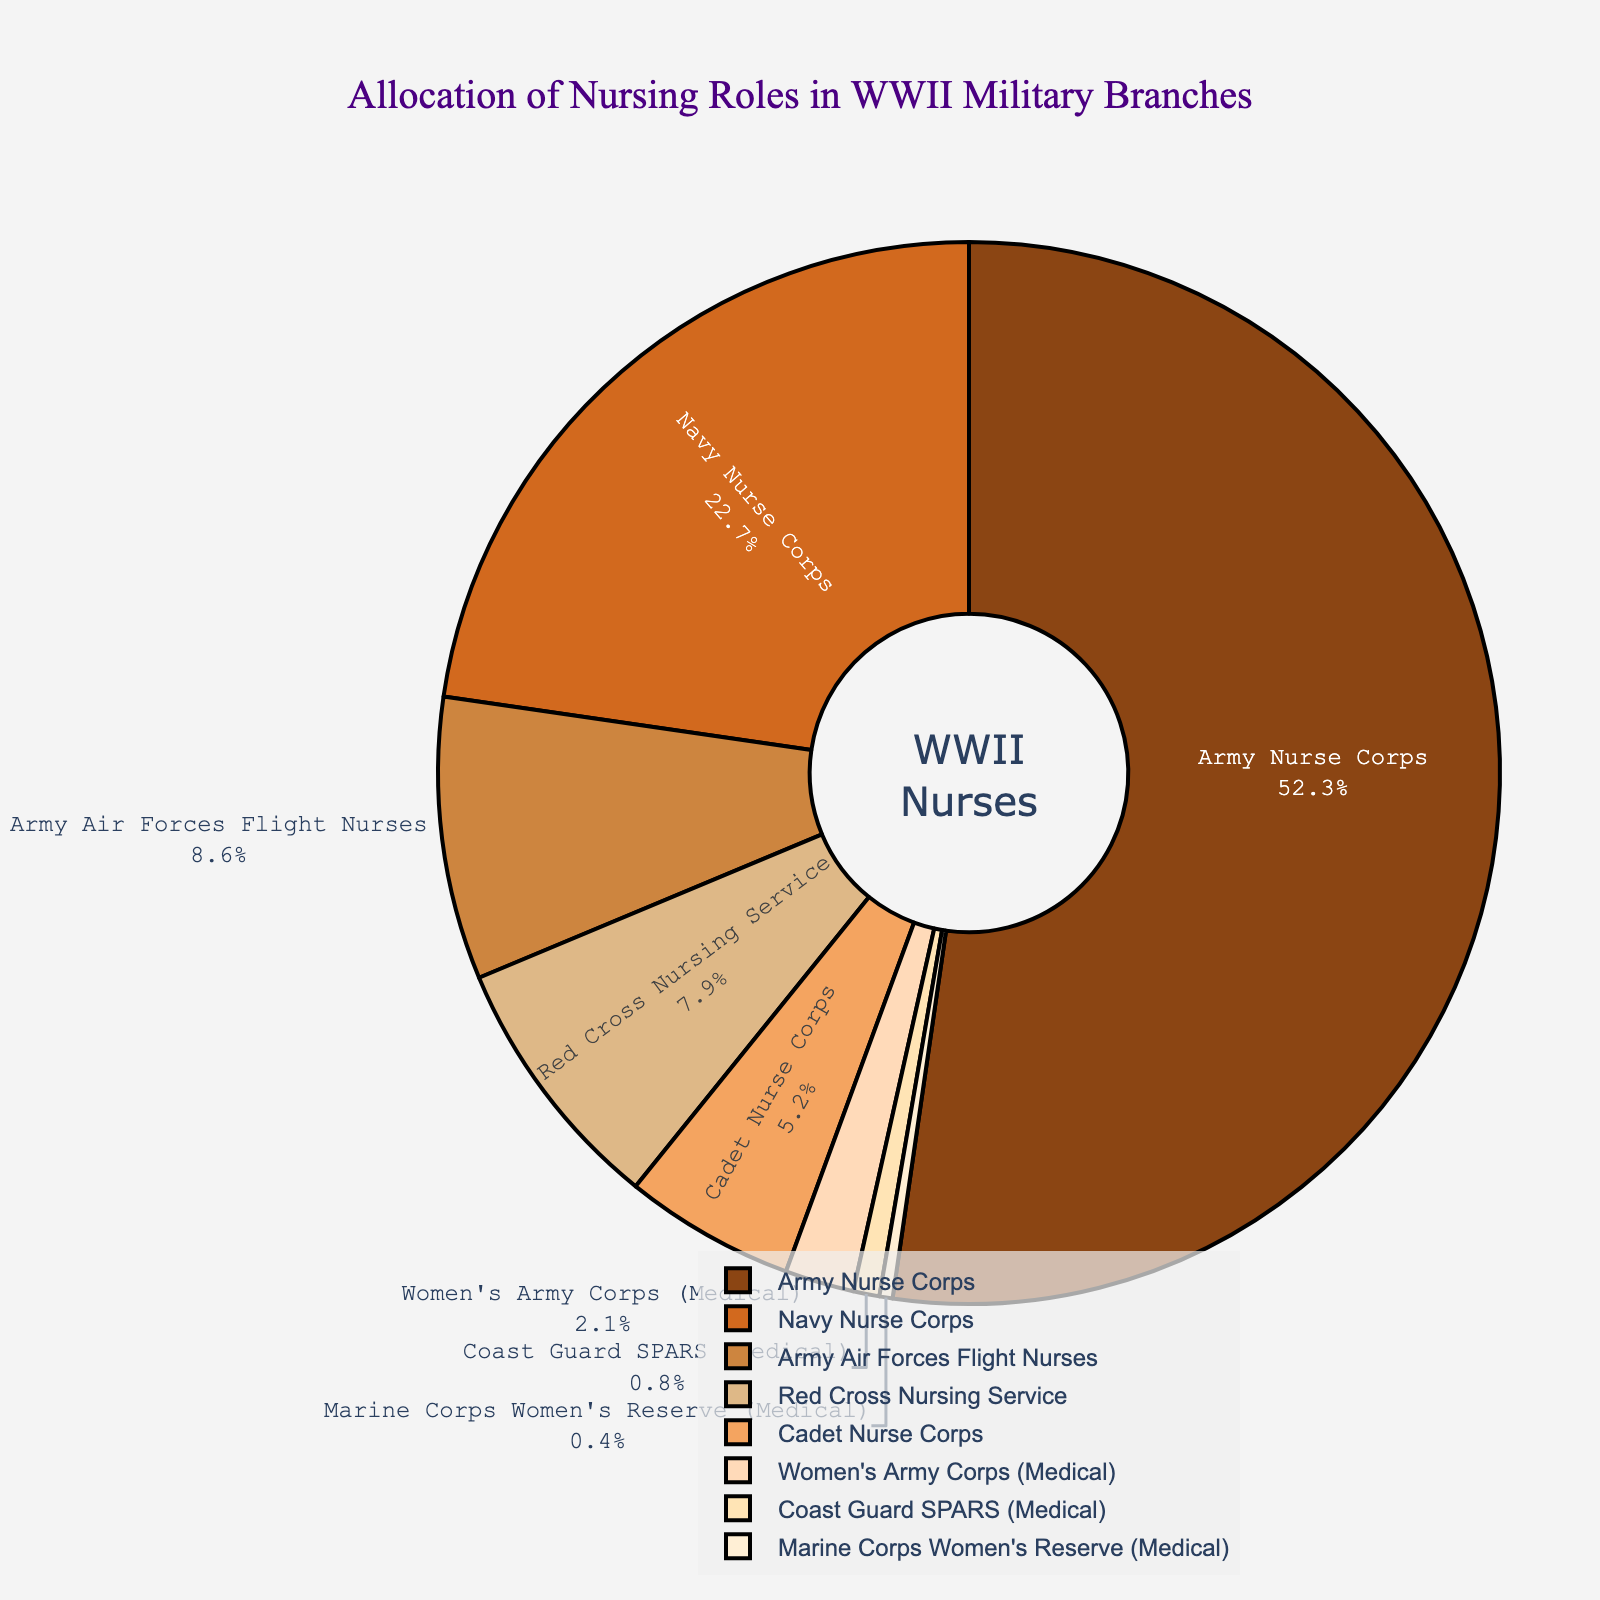Which branch has the largest allocation of nursing roles? The Army Nurse Corps section of the pie chart is the largest, occupying more than half of the chart. This indicates that the Army Nurse Corps has the highest percentage allocation among all branches.
Answer: Army Nurse Corps What is the combined percentage of the Navy Nurse Corps and the Red Cross Nursing Service? The percentage for the Navy Nurse Corps is 22.7% and for the Red Cross Nursing Service is 7.9%. Adding these two percentages together gives 22.7 + 7.9 = 30.6%.
Answer: 30.6% Which branch has a smaller allocation of nursing roles, the Women's Army Corps (Medical) or the Coast Guard SPARS (Medical)? By comparing the two sections in the pie chart, the Women's Army Corps (Medical) has an allocation of 2.1%, while the Coast Guard SPARS (Medical) has an allocation of 0.8%. Thus, the Coast Guard SPARS (Medical) has a smaller allocation.
Answer: Coast Guard SPARS (Medical) How does the allocation of the Army Air Forces Flight Nurses compare to that of the Cadet Nurse Corps? The Army Air Forces Flight Nurses has an allocation of 8.6%, which is greater than the 5.2% allocation of the Cadet Nurse Corps.
Answer: Greater Which color represents the Red Cross Nursing Service? By observing the pie chart, the Red Cross Nursing Service is represented by the fourth color in the sequence which is a shade of brown.
Answer: A shade of brown What is the difference between the percentage allocation of the Army Nurse Corps and the Marine Corps Women's Reserve (Medical)? The Army Nurse Corps has an allocation of 52.3%, and the Marine Corps Women's Reserve (Medical) has an allocation of 0.4%. The difference between these allocations is 52.3 - 0.4 = 51.9%.
Answer: 51.9% If you combine the percentages of branches with less than 10% allocation, what would be the total? The branches with less than 10% allocation are Army Air Forces Flight Nurses (8.6%), Red Cross Nursing Service (7.9%), Cadet Nurse Corps (5.2%), Women's Army Corps (Medical) (2.1%), Coast Guard SPARS (Medical) (0.8%), and Marine Corps Women's Reserve (Medical) (0.4%). Summing these together, 8.6 + 7.9 + 5.2 + 2.1 + 0.8 + 0.4 = 25%.
Answer: 25% What is the visual difference in allocation between the branches with the smallest and largest portions in the pie chart? The Army Nurse Corps has the largest portion at 52.3%, which visually takes more than half of the pie chart. The Marine Corps Women's Reserve (Medical) has the smallest portion with 0.4%, represented by a very small sliver of the pie chart.
Answer: Largest: Army Nurse Corps; Smallest: Marine Corps Women's Reserve (Medical) Which two branches combined make up almost 75% of the nursing roles? The Army Nurse Corps has 52.3% and the Navy Nurse Corps has 22.7%. When combined, they sum up to 52.3 + 22.7 = 75%.
Answer: Army Nurse Corps and Navy Nurse Corps 